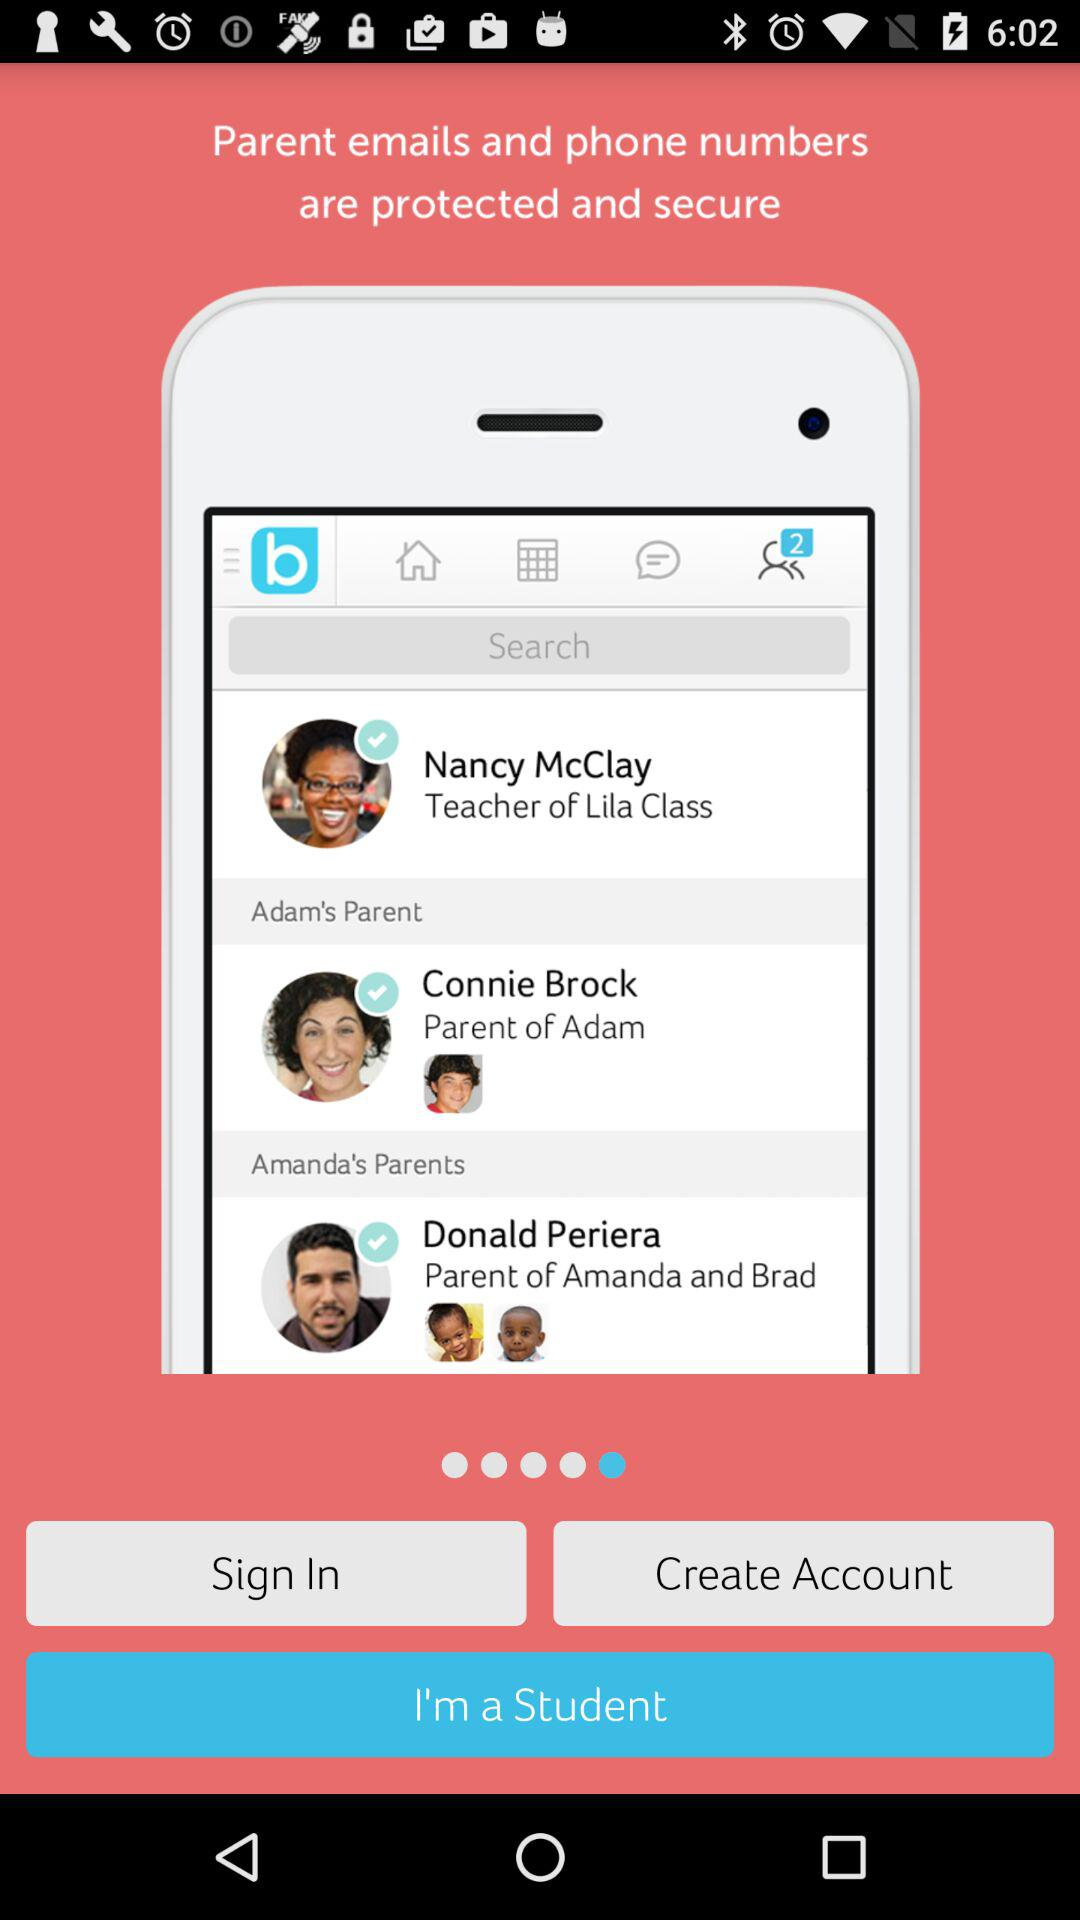Who is the teacher of Lila's class? The teacher of Lila's class is Nancy McClay. 